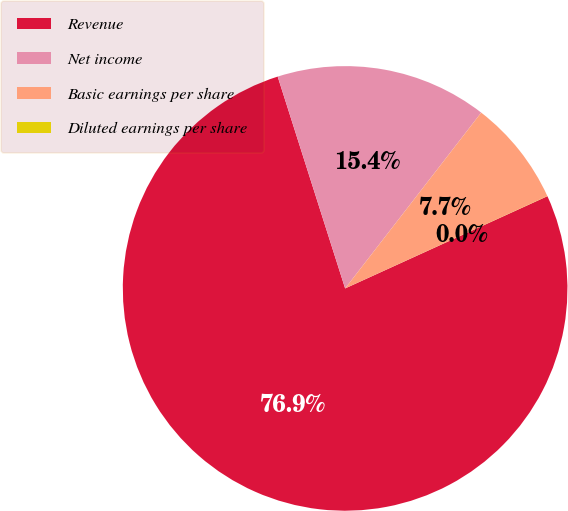Convert chart. <chart><loc_0><loc_0><loc_500><loc_500><pie_chart><fcel>Revenue<fcel>Net income<fcel>Basic earnings per share<fcel>Diluted earnings per share<nl><fcel>76.91%<fcel>15.39%<fcel>7.7%<fcel>0.01%<nl></chart> 